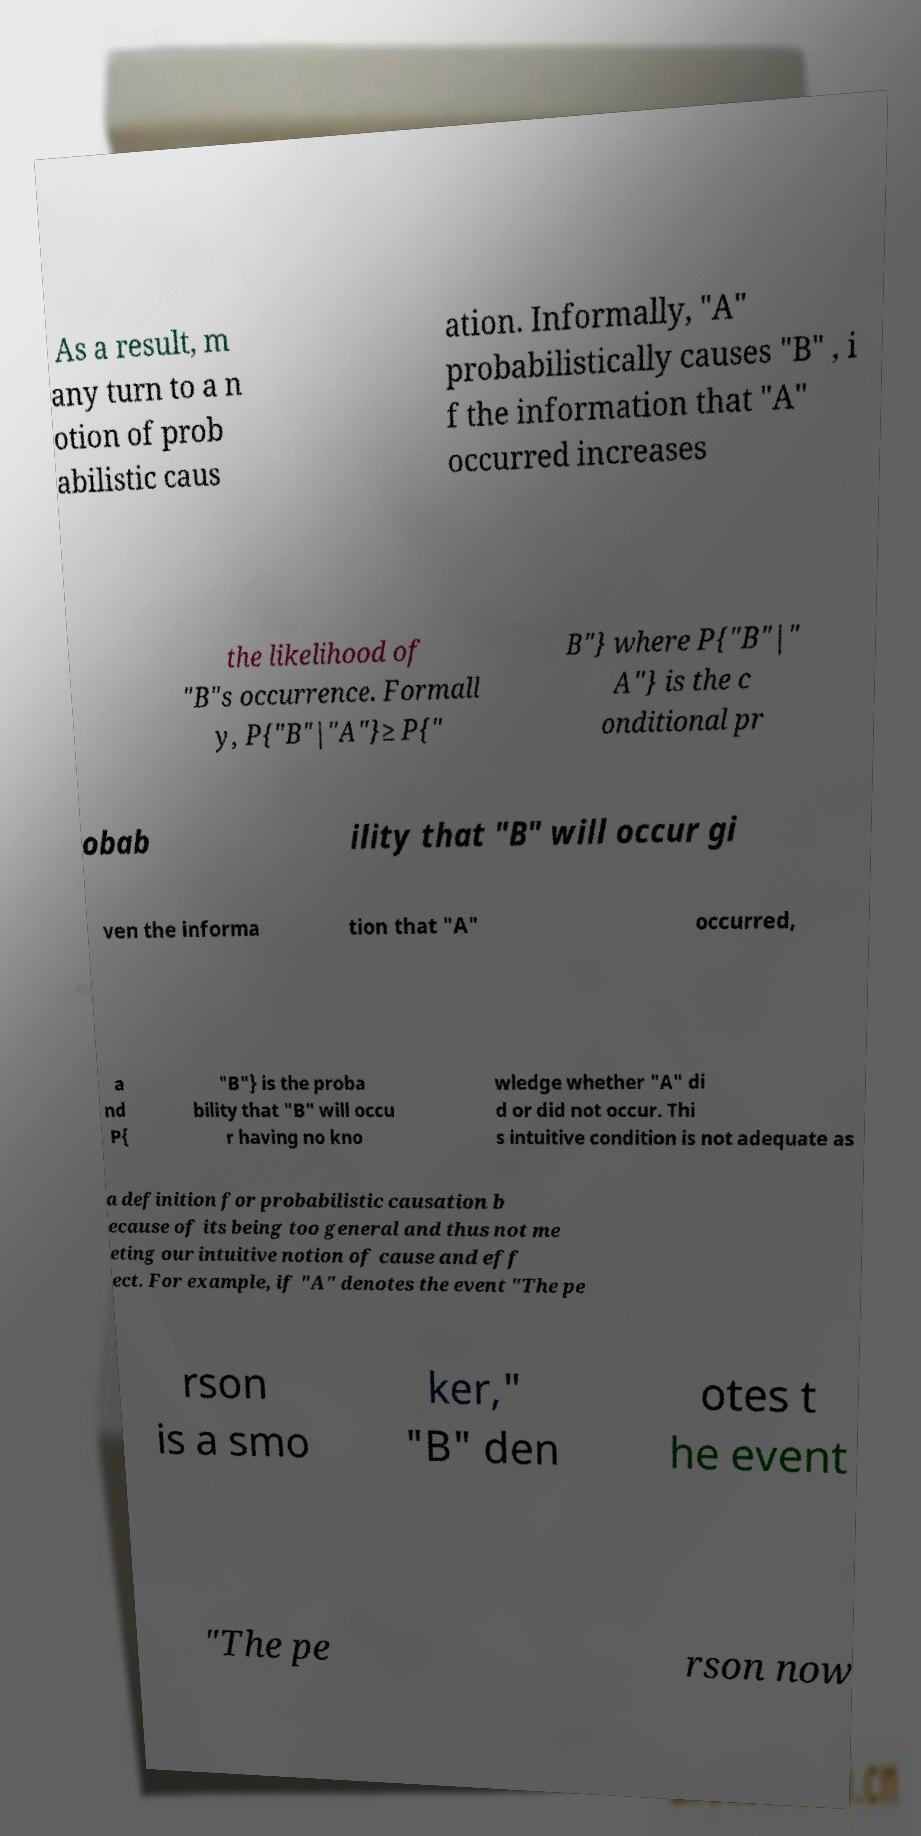What messages or text are displayed in this image? I need them in a readable, typed format. As a result, m any turn to a n otion of prob abilistic caus ation. Informally, "A" probabilistically causes "B" , i f the information that "A" occurred increases the likelihood of "B"s occurrence. Formall y, P{"B"|"A"}≥ P{" B"} where P{"B"|" A"} is the c onditional pr obab ility that "B" will occur gi ven the informa tion that "A" occurred, a nd P{ "B"} is the proba bility that "B" will occu r having no kno wledge whether "A" di d or did not occur. Thi s intuitive condition is not adequate as a definition for probabilistic causation b ecause of its being too general and thus not me eting our intuitive notion of cause and eff ect. For example, if "A" denotes the event "The pe rson is a smo ker," "B" den otes t he event "The pe rson now 